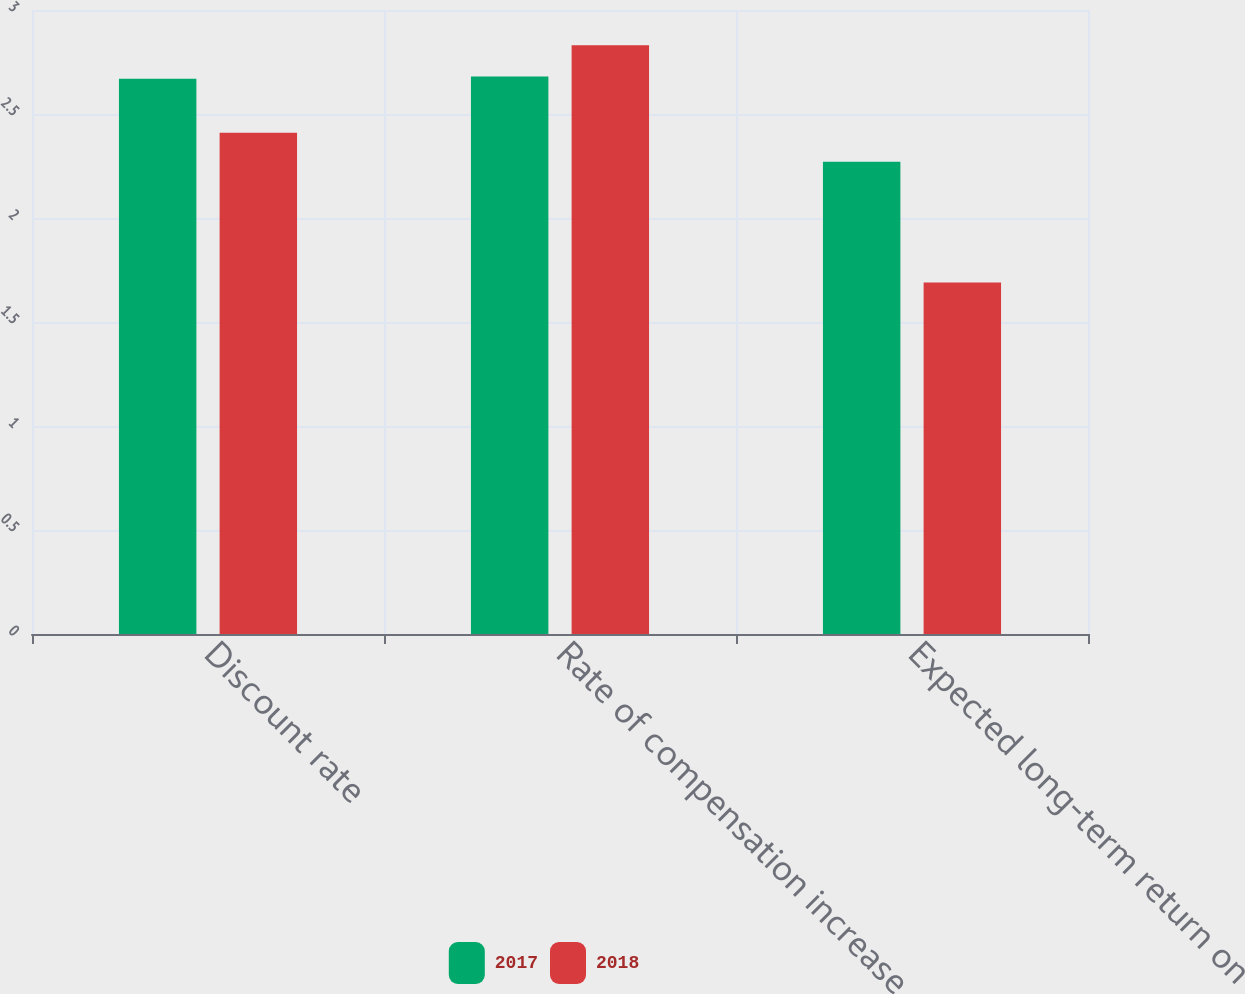Convert chart to OTSL. <chart><loc_0><loc_0><loc_500><loc_500><stacked_bar_chart><ecel><fcel>Discount rate<fcel>Rate of compensation increase<fcel>Expected long-term return on<nl><fcel>2017<fcel>2.67<fcel>2.68<fcel>2.27<nl><fcel>2018<fcel>2.41<fcel>2.83<fcel>1.69<nl></chart> 